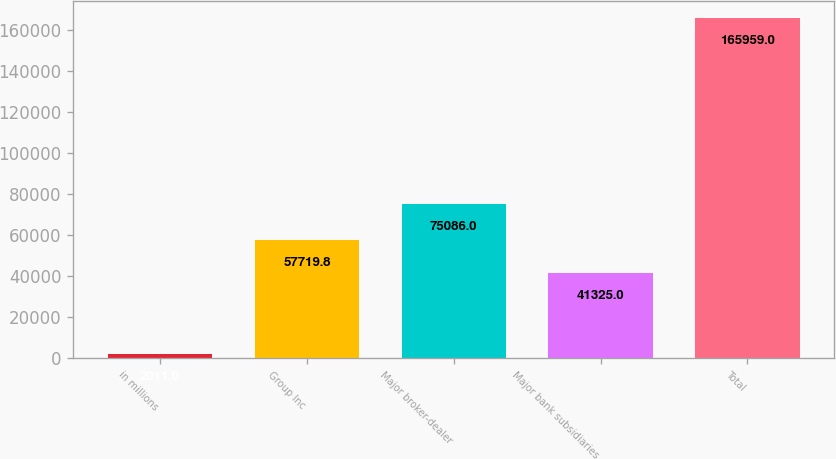Convert chart. <chart><loc_0><loc_0><loc_500><loc_500><bar_chart><fcel>in millions<fcel>Group Inc<fcel>Major broker-dealer<fcel>Major bank subsidiaries<fcel>Total<nl><fcel>2011<fcel>57719.8<fcel>75086<fcel>41325<fcel>165959<nl></chart> 